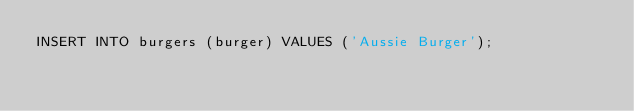Convert code to text. <code><loc_0><loc_0><loc_500><loc_500><_SQL_>INSERT INTO burgers (burger) VALUES ('Aussie Burger');
</code> 